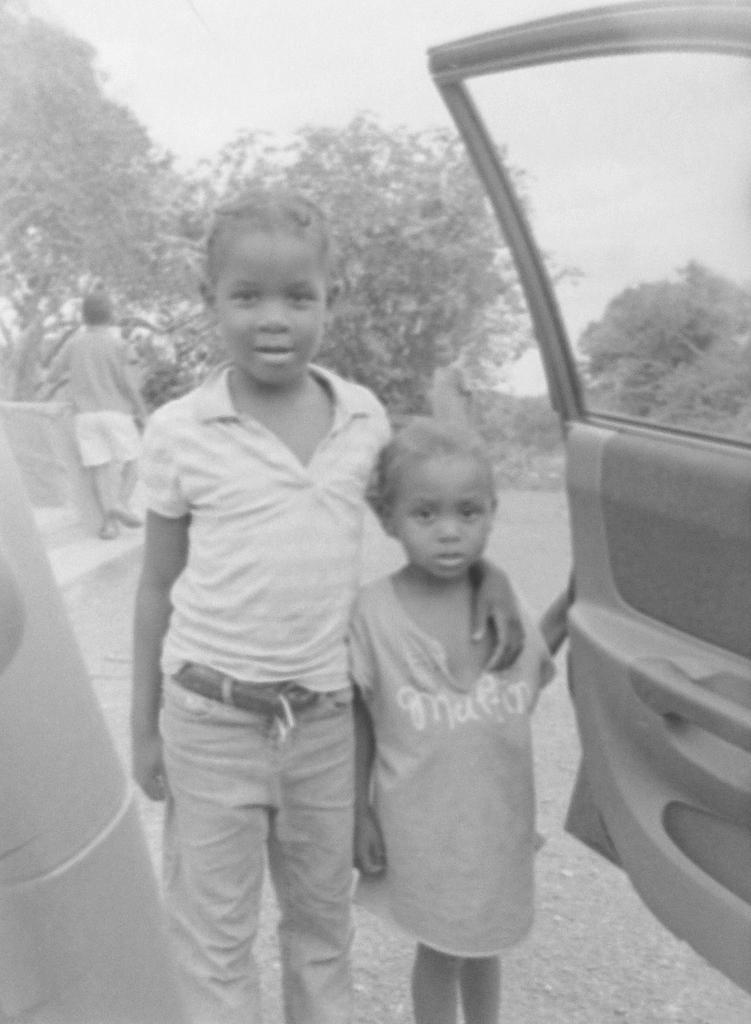Can you describe this image briefly? In this image there are persons standing in the center. On the right side there is a door. In the background there are trees and there is a person standing. 